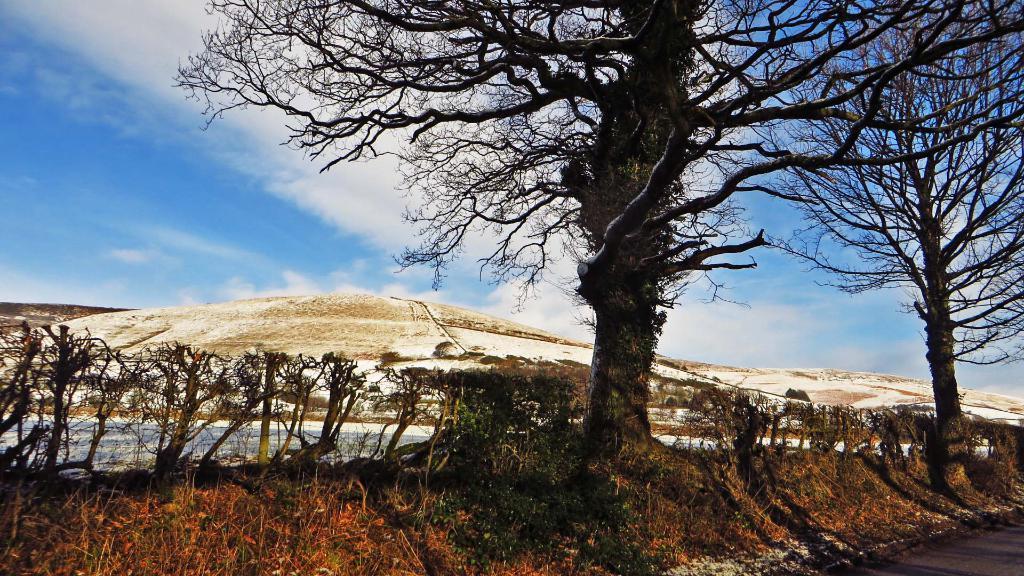Please provide a concise description of this image. Sky is cloudy. Here we can see trees and plants. Background there are mountains. 